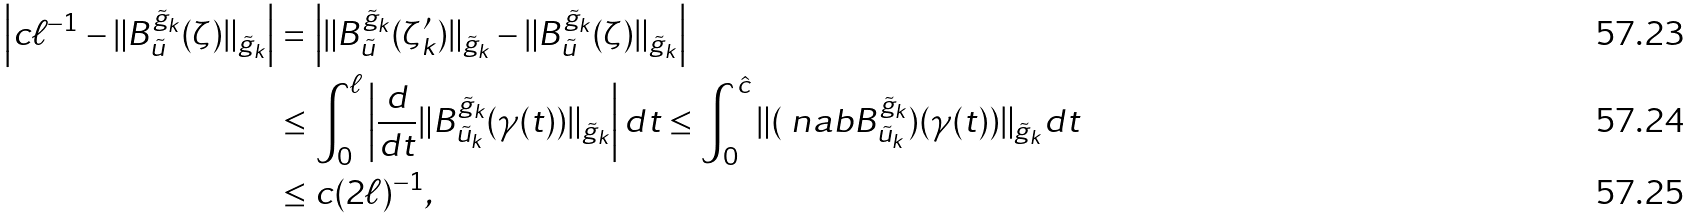<formula> <loc_0><loc_0><loc_500><loc_500>\left | c \ell ^ { - 1 } - \| B _ { \tilde { u } } ^ { \tilde { g } _ { k } } ( \zeta ) \| _ { \tilde { g } _ { k } } \right | & = \left | \| B _ { \tilde { u } } ^ { \tilde { g } _ { k } } ( \zeta _ { k } ^ { \prime } ) \| _ { \tilde { g } _ { k } } - \| B _ { \tilde { u } } ^ { \tilde { g } _ { k } } ( \zeta ) \| _ { \tilde { g } _ { k } } \right | \\ & \leq \int _ { 0 } ^ { \ell } \left | { \frac { d } { d t } } \| B _ { \tilde { u } _ { k } } ^ { \tilde { g } _ { k } } ( \gamma ( t ) ) \| _ { \tilde { g } _ { k } } \right | d t \leq \int _ { 0 } ^ { \hat { c } } \| ( \ n a b B _ { \tilde { u } _ { k } } ^ { \tilde { g } _ { k } } ) ( \gamma ( t ) ) \| _ { \tilde { g } _ { k } } d t \\ & \leq c ( 2 \ell ) ^ { - 1 } ,</formula> 